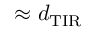Convert formula to latex. <formula><loc_0><loc_0><loc_500><loc_500>\approx d _ { T I R }</formula> 